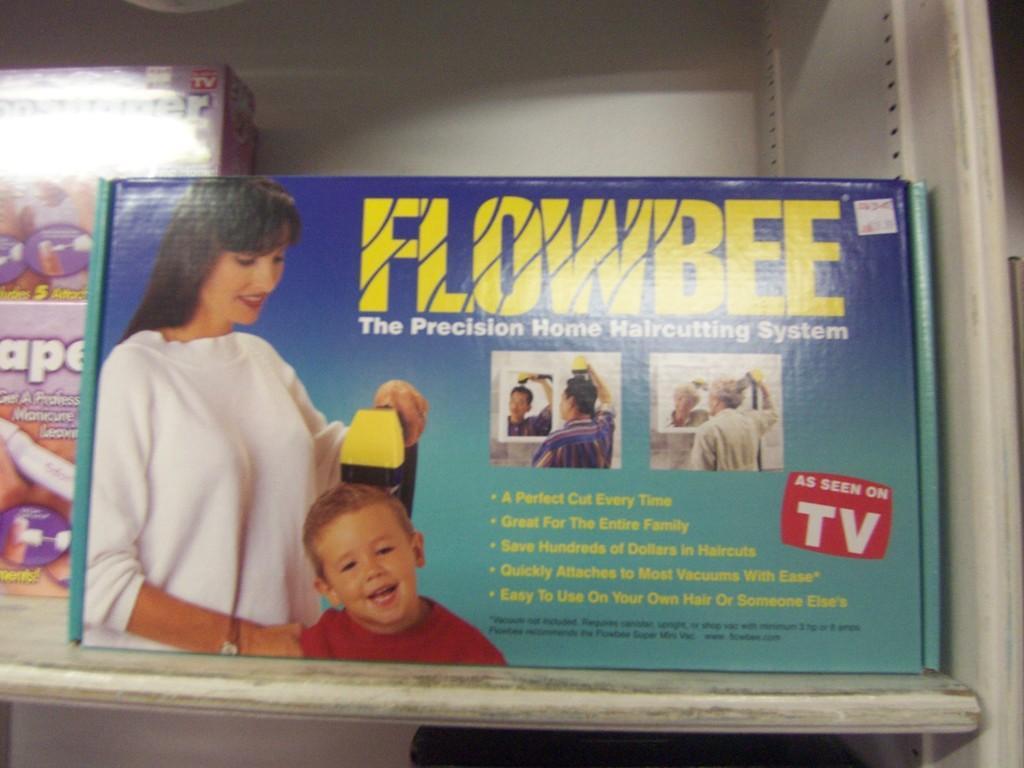Describe this image in one or two sentences. In the center of the image we can see boxes placed in the shelf. 